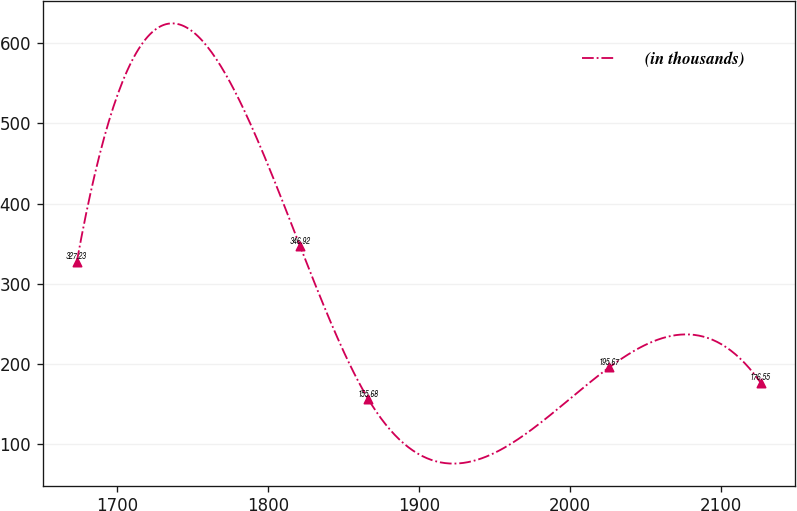Convert chart. <chart><loc_0><loc_0><loc_500><loc_500><line_chart><ecel><fcel>(in thousands)<nl><fcel>1673.09<fcel>327.23<nl><fcel>1821.13<fcel>346.92<nl><fcel>1866.48<fcel>155.68<nl><fcel>2026.13<fcel>195.67<nl><fcel>2126.54<fcel>176.55<nl></chart> 